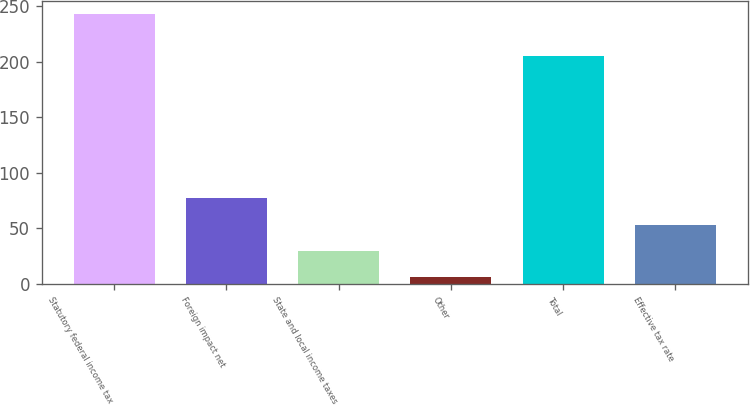Convert chart to OTSL. <chart><loc_0><loc_0><loc_500><loc_500><bar_chart><fcel>Statutory federal income tax<fcel>Foreign impact net<fcel>State and local income taxes<fcel>Other<fcel>Total<fcel>Effective tax rate<nl><fcel>242.6<fcel>76.91<fcel>29.57<fcel>5.9<fcel>204.7<fcel>53.24<nl></chart> 